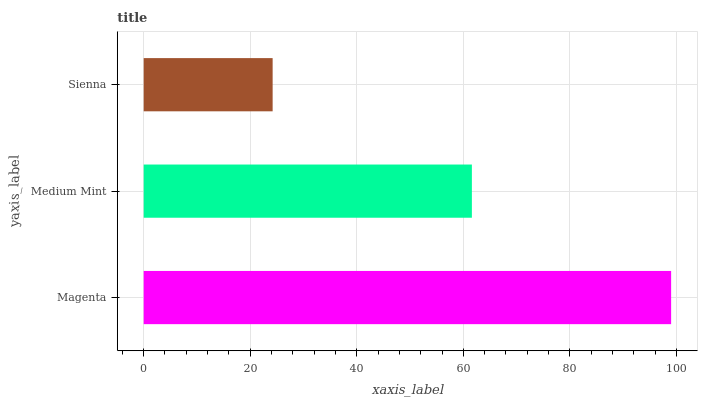Is Sienna the minimum?
Answer yes or no. Yes. Is Magenta the maximum?
Answer yes or no. Yes. Is Medium Mint the minimum?
Answer yes or no. No. Is Medium Mint the maximum?
Answer yes or no. No. Is Magenta greater than Medium Mint?
Answer yes or no. Yes. Is Medium Mint less than Magenta?
Answer yes or no. Yes. Is Medium Mint greater than Magenta?
Answer yes or no. No. Is Magenta less than Medium Mint?
Answer yes or no. No. Is Medium Mint the high median?
Answer yes or no. Yes. Is Medium Mint the low median?
Answer yes or no. Yes. Is Magenta the high median?
Answer yes or no. No. Is Sienna the low median?
Answer yes or no. No. 